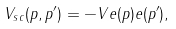<formula> <loc_0><loc_0><loc_500><loc_500>V _ { s c } ( { p , p ^ { \prime } } ) = - V e ( { p } ) e ( { p ^ { \prime } } ) ,</formula> 